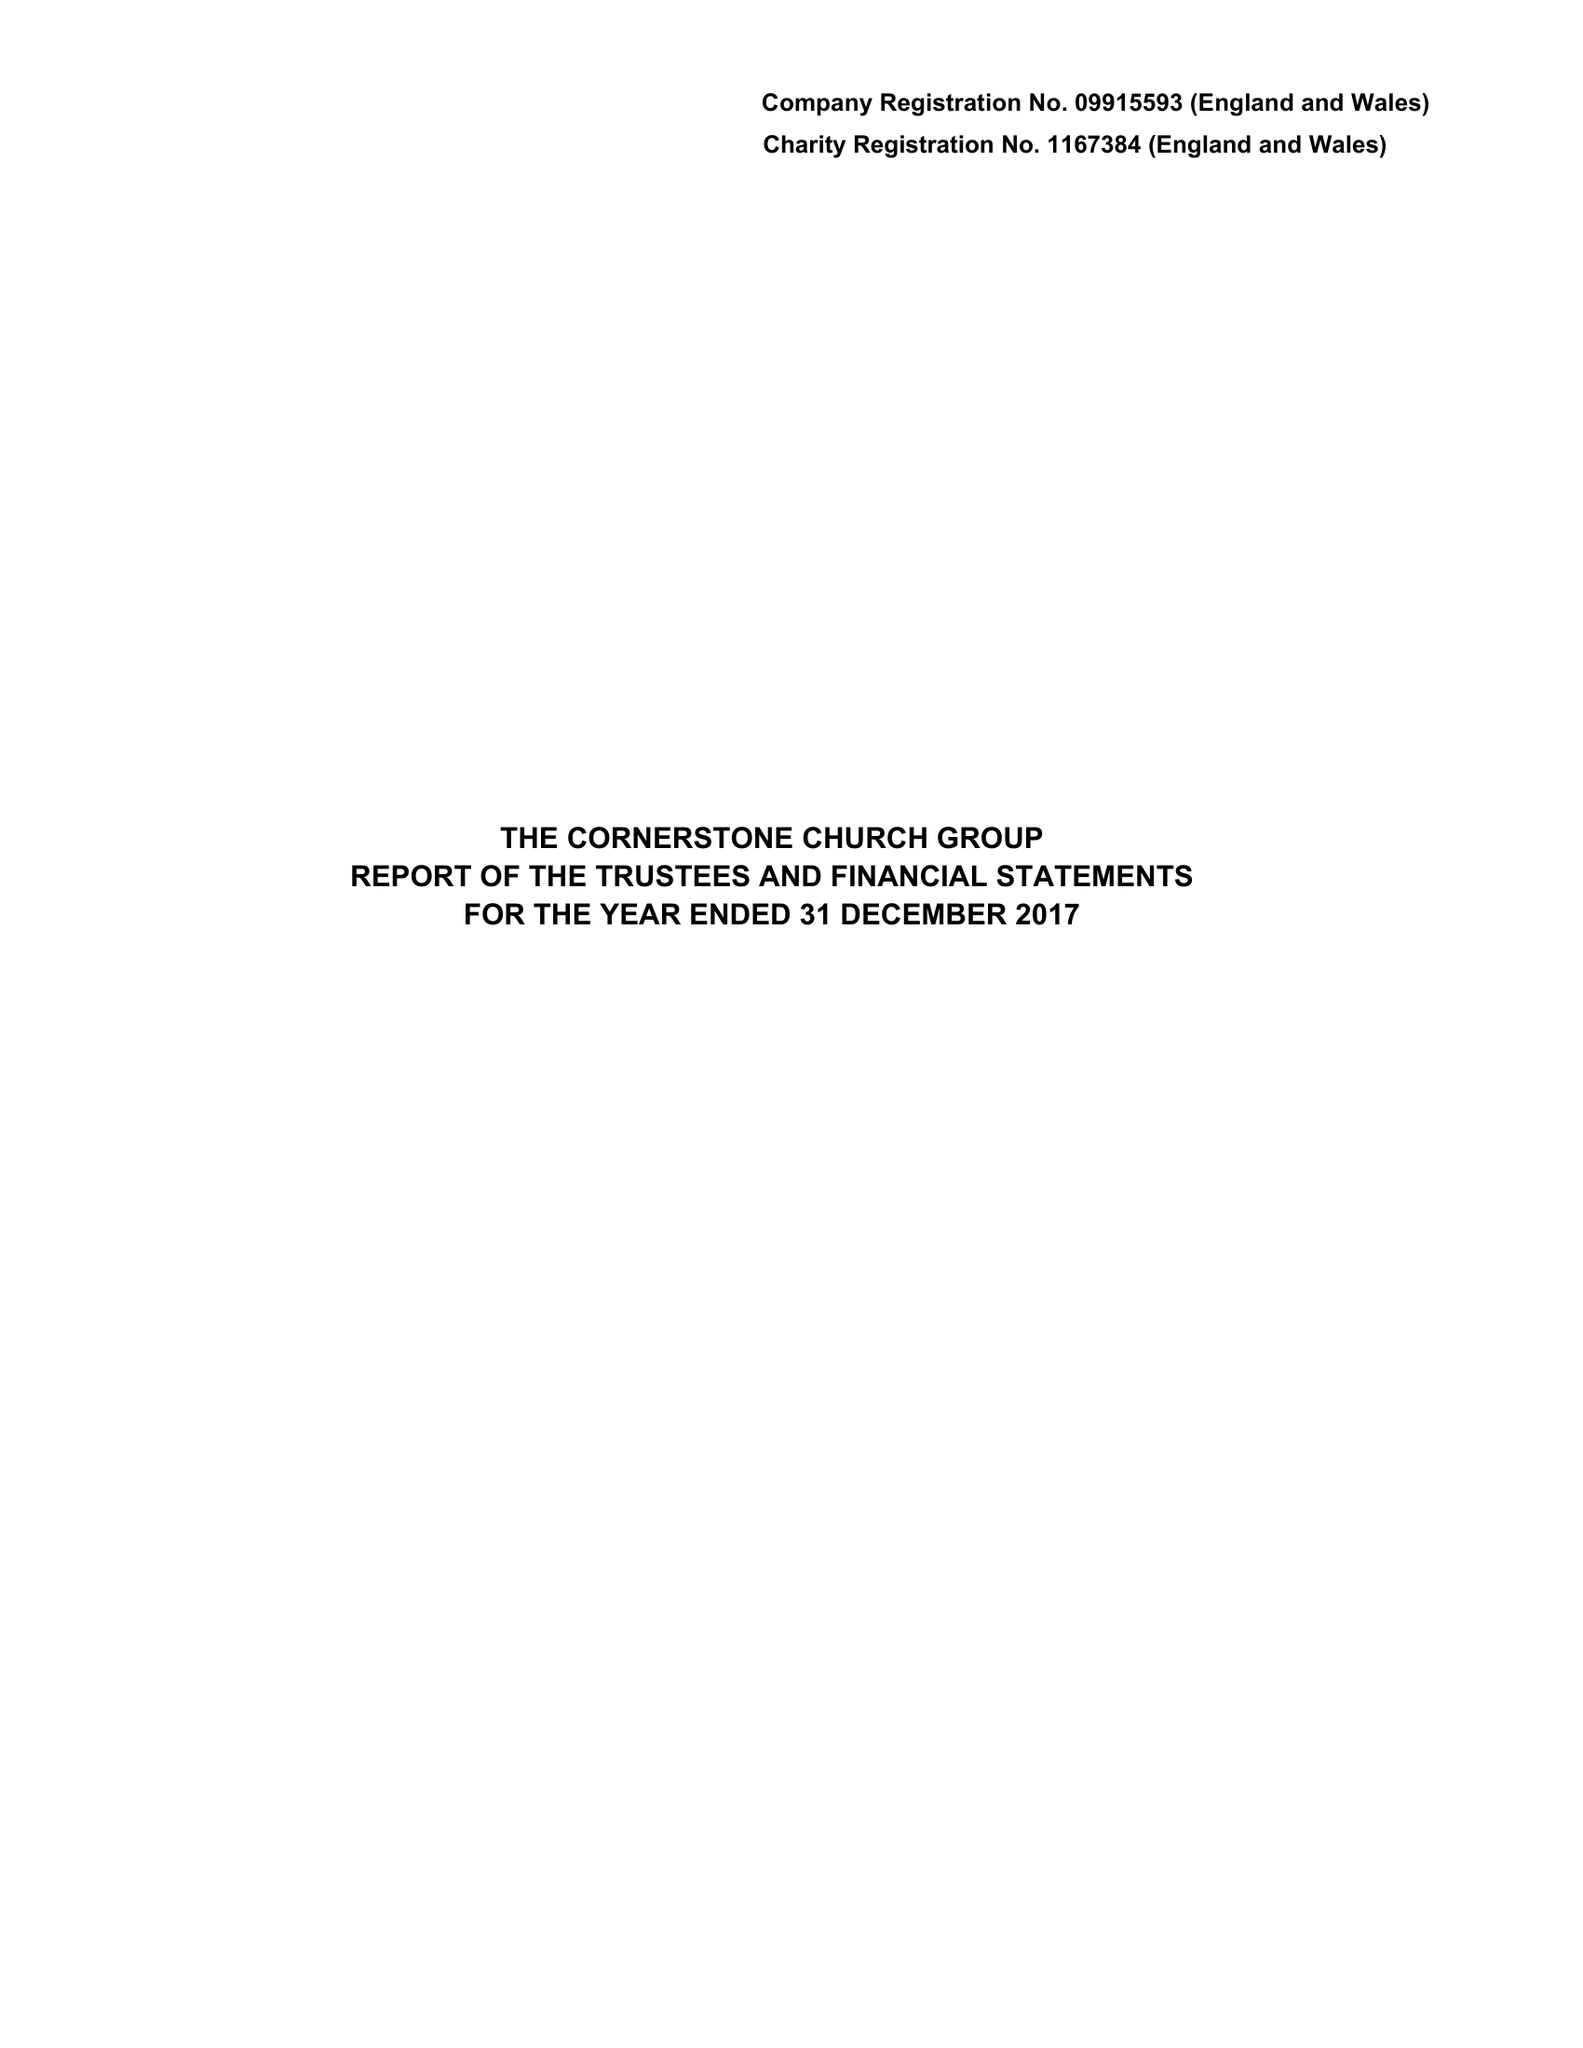What is the value for the spending_annually_in_british_pounds?
Answer the question using a single word or phrase. 83339.00 